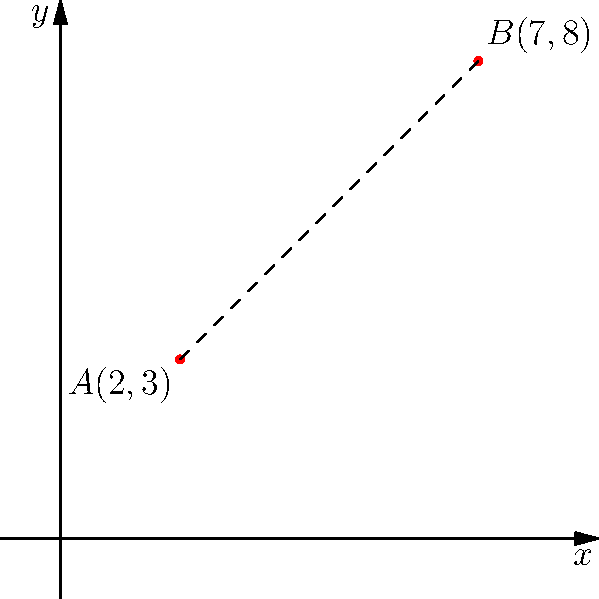On the coordinate plane shown above, points $A(2,3)$ and $B(7,8)$ are given. Calculate the distance between these two points. To find the distance between two points on a coordinate plane, we can use the distance formula:

$$d = \sqrt{(x_2-x_1)^2 + (y_2-y_1)^2}$$

Where $(x_1,y_1)$ are the coordinates of the first point and $(x_2,y_2)$ are the coordinates of the second point.

Let's solve this step-by-step:

1) Identify the coordinates:
   Point $A: (x_1,y_1) = (2,3)$
   Point $B: (x_2,y_2) = (7,8)$

2) Plug these values into the distance formula:
   $$d = \sqrt{(7-2)^2 + (8-3)^2}$$

3) Simplify inside the parentheses:
   $$d = \sqrt{5^2 + 5^2}$$

4) Calculate the squares:
   $$d = \sqrt{25 + 25}$$

5) Add inside the square root:
   $$d = \sqrt{50}$$

6) Simplify the square root:
   $$d = 5\sqrt{2}$$

Therefore, the distance between points $A$ and $B$ is $5\sqrt{2}$ units.
Answer: $5\sqrt{2}$ units 